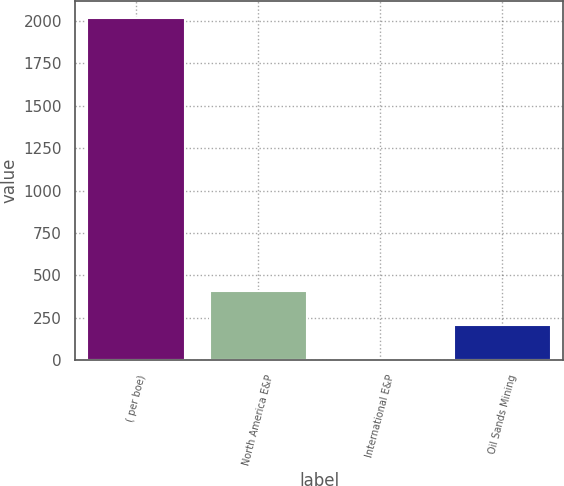Convert chart to OTSL. <chart><loc_0><loc_0><loc_500><loc_500><bar_chart><fcel>( per boe)<fcel>North America E&P<fcel>International E&P<fcel>Oil Sands Mining<nl><fcel>2015<fcel>408.56<fcel>6.95<fcel>207.75<nl></chart> 